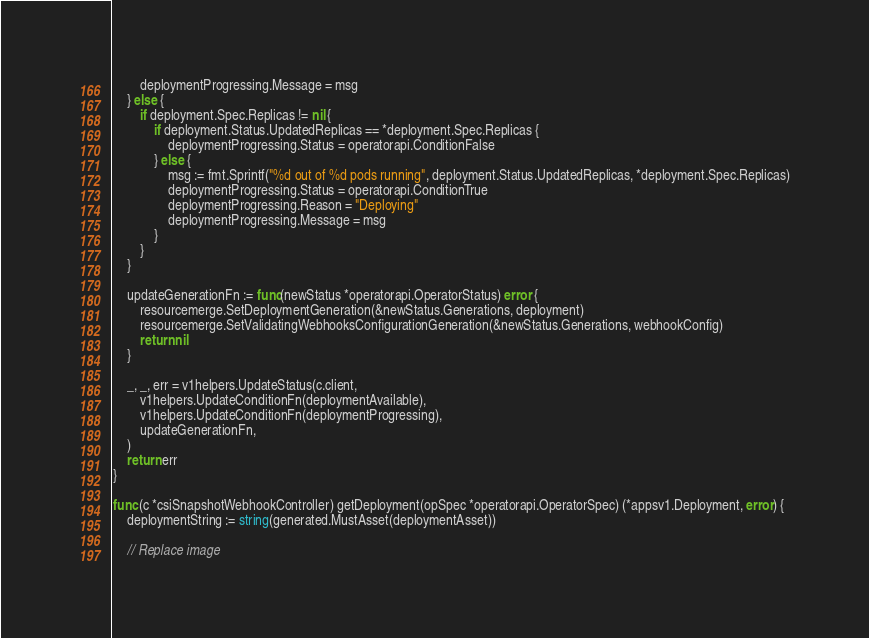Convert code to text. <code><loc_0><loc_0><loc_500><loc_500><_Go_>		deploymentProgressing.Message = msg
	} else {
		if deployment.Spec.Replicas != nil {
			if deployment.Status.UpdatedReplicas == *deployment.Spec.Replicas {
				deploymentProgressing.Status = operatorapi.ConditionFalse
			} else {
				msg := fmt.Sprintf("%d out of %d pods running", deployment.Status.UpdatedReplicas, *deployment.Spec.Replicas)
				deploymentProgressing.Status = operatorapi.ConditionTrue
				deploymentProgressing.Reason = "Deploying"
				deploymentProgressing.Message = msg
			}
		}
	}

	updateGenerationFn := func(newStatus *operatorapi.OperatorStatus) error {
		resourcemerge.SetDeploymentGeneration(&newStatus.Generations, deployment)
		resourcemerge.SetValidatingWebhooksConfigurationGeneration(&newStatus.Generations, webhookConfig)
		return nil
	}

	_, _, err = v1helpers.UpdateStatus(c.client,
		v1helpers.UpdateConditionFn(deploymentAvailable),
		v1helpers.UpdateConditionFn(deploymentProgressing),
		updateGenerationFn,
	)
	return err
}

func (c *csiSnapshotWebhookController) getDeployment(opSpec *operatorapi.OperatorSpec) (*appsv1.Deployment, error) {
	deploymentString := string(generated.MustAsset(deploymentAsset))

	// Replace image</code> 